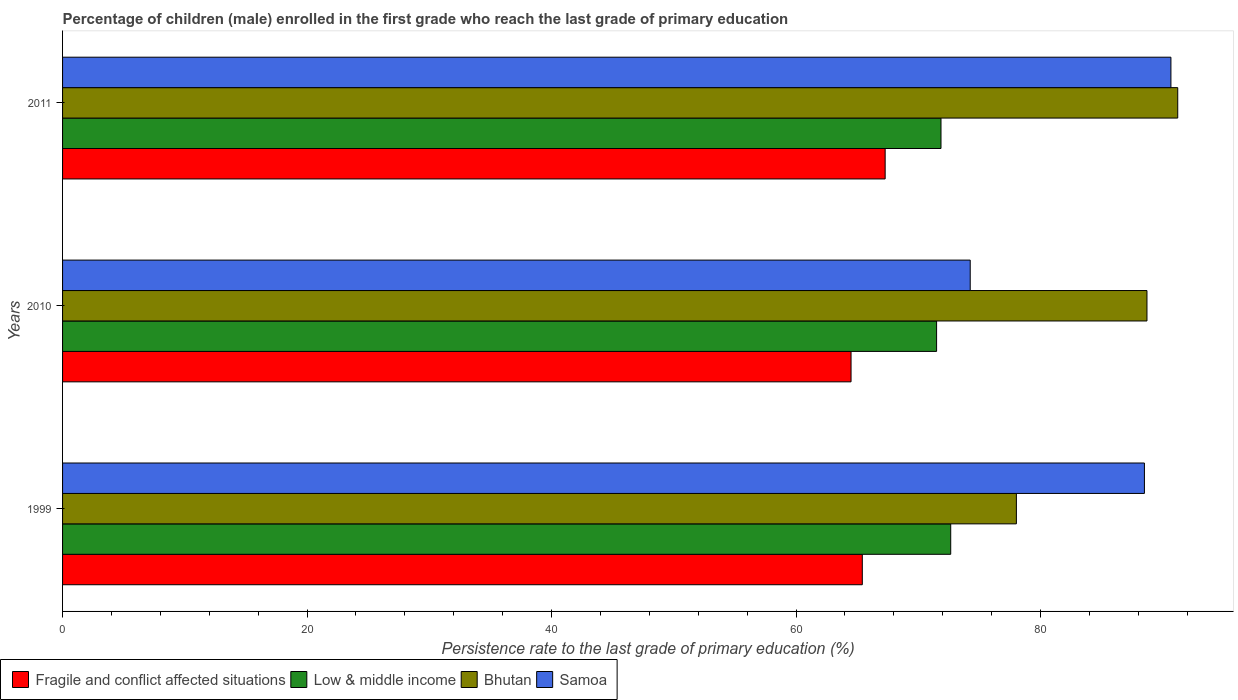How many different coloured bars are there?
Ensure brevity in your answer.  4. How many groups of bars are there?
Offer a very short reply. 3. Are the number of bars per tick equal to the number of legend labels?
Provide a succinct answer. Yes. How many bars are there on the 3rd tick from the top?
Provide a short and direct response. 4. How many bars are there on the 3rd tick from the bottom?
Your answer should be compact. 4. In how many cases, is the number of bars for a given year not equal to the number of legend labels?
Give a very brief answer. 0. What is the persistence rate of children in Fragile and conflict affected situations in 2010?
Provide a succinct answer. 64.5. Across all years, what is the maximum persistence rate of children in Low & middle income?
Ensure brevity in your answer.  72.65. Across all years, what is the minimum persistence rate of children in Fragile and conflict affected situations?
Provide a succinct answer. 64.5. In which year was the persistence rate of children in Bhutan maximum?
Keep it short and to the point. 2011. In which year was the persistence rate of children in Samoa minimum?
Give a very brief answer. 2010. What is the total persistence rate of children in Fragile and conflict affected situations in the graph?
Provide a succinct answer. 197.21. What is the difference between the persistence rate of children in Samoa in 2010 and that in 2011?
Provide a succinct answer. -16.42. What is the difference between the persistence rate of children in Low & middle income in 2010 and the persistence rate of children in Samoa in 2011?
Your answer should be very brief. -19.17. What is the average persistence rate of children in Low & middle income per year?
Make the answer very short. 72. In the year 2011, what is the difference between the persistence rate of children in Fragile and conflict affected situations and persistence rate of children in Samoa?
Your answer should be compact. -23.38. What is the ratio of the persistence rate of children in Fragile and conflict affected situations in 1999 to that in 2010?
Ensure brevity in your answer.  1.01. Is the persistence rate of children in Samoa in 2010 less than that in 2011?
Your answer should be very brief. Yes. What is the difference between the highest and the second highest persistence rate of children in Fragile and conflict affected situations?
Make the answer very short. 1.87. What is the difference between the highest and the lowest persistence rate of children in Fragile and conflict affected situations?
Provide a succinct answer. 2.79. Is the sum of the persistence rate of children in Low & middle income in 2010 and 2011 greater than the maximum persistence rate of children in Fragile and conflict affected situations across all years?
Provide a succinct answer. Yes. Is it the case that in every year, the sum of the persistence rate of children in Bhutan and persistence rate of children in Samoa is greater than the sum of persistence rate of children in Low & middle income and persistence rate of children in Fragile and conflict affected situations?
Your response must be concise. Yes. What does the 2nd bar from the top in 1999 represents?
Ensure brevity in your answer.  Bhutan. What does the 3rd bar from the bottom in 2010 represents?
Offer a terse response. Bhutan. Is it the case that in every year, the sum of the persistence rate of children in Fragile and conflict affected situations and persistence rate of children in Samoa is greater than the persistence rate of children in Low & middle income?
Offer a very short reply. Yes. Are all the bars in the graph horizontal?
Offer a terse response. Yes. Does the graph contain any zero values?
Make the answer very short. No. Does the graph contain grids?
Make the answer very short. No. Where does the legend appear in the graph?
Keep it short and to the point. Bottom left. What is the title of the graph?
Ensure brevity in your answer.  Percentage of children (male) enrolled in the first grade who reach the last grade of primary education. Does "South Asia" appear as one of the legend labels in the graph?
Your response must be concise. No. What is the label or title of the X-axis?
Your answer should be very brief. Persistence rate to the last grade of primary education (%). What is the Persistence rate to the last grade of primary education (%) of Fragile and conflict affected situations in 1999?
Give a very brief answer. 65.42. What is the Persistence rate to the last grade of primary education (%) of Low & middle income in 1999?
Give a very brief answer. 72.65. What is the Persistence rate to the last grade of primary education (%) in Bhutan in 1999?
Provide a short and direct response. 78.02. What is the Persistence rate to the last grade of primary education (%) of Samoa in 1999?
Offer a very short reply. 88.5. What is the Persistence rate to the last grade of primary education (%) in Fragile and conflict affected situations in 2010?
Your answer should be compact. 64.5. What is the Persistence rate to the last grade of primary education (%) of Low & middle income in 2010?
Your response must be concise. 71.49. What is the Persistence rate to the last grade of primary education (%) of Bhutan in 2010?
Offer a very short reply. 88.7. What is the Persistence rate to the last grade of primary education (%) of Samoa in 2010?
Give a very brief answer. 74.25. What is the Persistence rate to the last grade of primary education (%) in Fragile and conflict affected situations in 2011?
Your answer should be very brief. 67.29. What is the Persistence rate to the last grade of primary education (%) of Low & middle income in 2011?
Offer a terse response. 71.86. What is the Persistence rate to the last grade of primary education (%) in Bhutan in 2011?
Keep it short and to the point. 91.22. What is the Persistence rate to the last grade of primary education (%) in Samoa in 2011?
Keep it short and to the point. 90.66. Across all years, what is the maximum Persistence rate to the last grade of primary education (%) in Fragile and conflict affected situations?
Provide a short and direct response. 67.29. Across all years, what is the maximum Persistence rate to the last grade of primary education (%) in Low & middle income?
Offer a very short reply. 72.65. Across all years, what is the maximum Persistence rate to the last grade of primary education (%) in Bhutan?
Offer a terse response. 91.22. Across all years, what is the maximum Persistence rate to the last grade of primary education (%) of Samoa?
Your answer should be compact. 90.66. Across all years, what is the minimum Persistence rate to the last grade of primary education (%) of Fragile and conflict affected situations?
Provide a succinct answer. 64.5. Across all years, what is the minimum Persistence rate to the last grade of primary education (%) of Low & middle income?
Provide a short and direct response. 71.49. Across all years, what is the minimum Persistence rate to the last grade of primary education (%) in Bhutan?
Offer a very short reply. 78.02. Across all years, what is the minimum Persistence rate to the last grade of primary education (%) of Samoa?
Offer a very short reply. 74.25. What is the total Persistence rate to the last grade of primary education (%) in Fragile and conflict affected situations in the graph?
Your response must be concise. 197.21. What is the total Persistence rate to the last grade of primary education (%) of Low & middle income in the graph?
Ensure brevity in your answer.  216. What is the total Persistence rate to the last grade of primary education (%) of Bhutan in the graph?
Offer a terse response. 257.95. What is the total Persistence rate to the last grade of primary education (%) of Samoa in the graph?
Provide a succinct answer. 253.41. What is the difference between the Persistence rate to the last grade of primary education (%) of Fragile and conflict affected situations in 1999 and that in 2010?
Keep it short and to the point. 0.92. What is the difference between the Persistence rate to the last grade of primary education (%) of Low & middle income in 1999 and that in 2010?
Offer a very short reply. 1.16. What is the difference between the Persistence rate to the last grade of primary education (%) of Bhutan in 1999 and that in 2010?
Ensure brevity in your answer.  -10.68. What is the difference between the Persistence rate to the last grade of primary education (%) of Samoa in 1999 and that in 2010?
Your answer should be very brief. 14.25. What is the difference between the Persistence rate to the last grade of primary education (%) of Fragile and conflict affected situations in 1999 and that in 2011?
Ensure brevity in your answer.  -1.87. What is the difference between the Persistence rate to the last grade of primary education (%) in Low & middle income in 1999 and that in 2011?
Ensure brevity in your answer.  0.8. What is the difference between the Persistence rate to the last grade of primary education (%) of Bhutan in 1999 and that in 2011?
Offer a very short reply. -13.2. What is the difference between the Persistence rate to the last grade of primary education (%) of Samoa in 1999 and that in 2011?
Make the answer very short. -2.17. What is the difference between the Persistence rate to the last grade of primary education (%) of Fragile and conflict affected situations in 2010 and that in 2011?
Ensure brevity in your answer.  -2.79. What is the difference between the Persistence rate to the last grade of primary education (%) in Low & middle income in 2010 and that in 2011?
Ensure brevity in your answer.  -0.36. What is the difference between the Persistence rate to the last grade of primary education (%) in Bhutan in 2010 and that in 2011?
Offer a terse response. -2.52. What is the difference between the Persistence rate to the last grade of primary education (%) of Samoa in 2010 and that in 2011?
Make the answer very short. -16.42. What is the difference between the Persistence rate to the last grade of primary education (%) in Fragile and conflict affected situations in 1999 and the Persistence rate to the last grade of primary education (%) in Low & middle income in 2010?
Offer a terse response. -6.08. What is the difference between the Persistence rate to the last grade of primary education (%) in Fragile and conflict affected situations in 1999 and the Persistence rate to the last grade of primary education (%) in Bhutan in 2010?
Keep it short and to the point. -23.28. What is the difference between the Persistence rate to the last grade of primary education (%) in Fragile and conflict affected situations in 1999 and the Persistence rate to the last grade of primary education (%) in Samoa in 2010?
Your answer should be very brief. -8.83. What is the difference between the Persistence rate to the last grade of primary education (%) of Low & middle income in 1999 and the Persistence rate to the last grade of primary education (%) of Bhutan in 2010?
Make the answer very short. -16.05. What is the difference between the Persistence rate to the last grade of primary education (%) in Low & middle income in 1999 and the Persistence rate to the last grade of primary education (%) in Samoa in 2010?
Keep it short and to the point. -1.59. What is the difference between the Persistence rate to the last grade of primary education (%) in Bhutan in 1999 and the Persistence rate to the last grade of primary education (%) in Samoa in 2010?
Provide a succinct answer. 3.78. What is the difference between the Persistence rate to the last grade of primary education (%) in Fragile and conflict affected situations in 1999 and the Persistence rate to the last grade of primary education (%) in Low & middle income in 2011?
Offer a terse response. -6.44. What is the difference between the Persistence rate to the last grade of primary education (%) of Fragile and conflict affected situations in 1999 and the Persistence rate to the last grade of primary education (%) of Bhutan in 2011?
Ensure brevity in your answer.  -25.8. What is the difference between the Persistence rate to the last grade of primary education (%) in Fragile and conflict affected situations in 1999 and the Persistence rate to the last grade of primary education (%) in Samoa in 2011?
Offer a very short reply. -25.24. What is the difference between the Persistence rate to the last grade of primary education (%) of Low & middle income in 1999 and the Persistence rate to the last grade of primary education (%) of Bhutan in 2011?
Offer a terse response. -18.57. What is the difference between the Persistence rate to the last grade of primary education (%) of Low & middle income in 1999 and the Persistence rate to the last grade of primary education (%) of Samoa in 2011?
Keep it short and to the point. -18.01. What is the difference between the Persistence rate to the last grade of primary education (%) in Bhutan in 1999 and the Persistence rate to the last grade of primary education (%) in Samoa in 2011?
Your answer should be compact. -12.64. What is the difference between the Persistence rate to the last grade of primary education (%) of Fragile and conflict affected situations in 2010 and the Persistence rate to the last grade of primary education (%) of Low & middle income in 2011?
Your response must be concise. -7.36. What is the difference between the Persistence rate to the last grade of primary education (%) of Fragile and conflict affected situations in 2010 and the Persistence rate to the last grade of primary education (%) of Bhutan in 2011?
Provide a short and direct response. -26.72. What is the difference between the Persistence rate to the last grade of primary education (%) of Fragile and conflict affected situations in 2010 and the Persistence rate to the last grade of primary education (%) of Samoa in 2011?
Provide a succinct answer. -26.17. What is the difference between the Persistence rate to the last grade of primary education (%) of Low & middle income in 2010 and the Persistence rate to the last grade of primary education (%) of Bhutan in 2011?
Ensure brevity in your answer.  -19.73. What is the difference between the Persistence rate to the last grade of primary education (%) in Low & middle income in 2010 and the Persistence rate to the last grade of primary education (%) in Samoa in 2011?
Give a very brief answer. -19.17. What is the difference between the Persistence rate to the last grade of primary education (%) of Bhutan in 2010 and the Persistence rate to the last grade of primary education (%) of Samoa in 2011?
Your answer should be compact. -1.96. What is the average Persistence rate to the last grade of primary education (%) of Fragile and conflict affected situations per year?
Ensure brevity in your answer.  65.74. What is the average Persistence rate to the last grade of primary education (%) in Low & middle income per year?
Offer a very short reply. 72. What is the average Persistence rate to the last grade of primary education (%) of Bhutan per year?
Provide a succinct answer. 85.98. What is the average Persistence rate to the last grade of primary education (%) of Samoa per year?
Offer a terse response. 84.47. In the year 1999, what is the difference between the Persistence rate to the last grade of primary education (%) in Fragile and conflict affected situations and Persistence rate to the last grade of primary education (%) in Low & middle income?
Your answer should be very brief. -7.23. In the year 1999, what is the difference between the Persistence rate to the last grade of primary education (%) in Fragile and conflict affected situations and Persistence rate to the last grade of primary education (%) in Bhutan?
Ensure brevity in your answer.  -12.6. In the year 1999, what is the difference between the Persistence rate to the last grade of primary education (%) of Fragile and conflict affected situations and Persistence rate to the last grade of primary education (%) of Samoa?
Provide a short and direct response. -23.08. In the year 1999, what is the difference between the Persistence rate to the last grade of primary education (%) of Low & middle income and Persistence rate to the last grade of primary education (%) of Bhutan?
Your answer should be compact. -5.37. In the year 1999, what is the difference between the Persistence rate to the last grade of primary education (%) in Low & middle income and Persistence rate to the last grade of primary education (%) in Samoa?
Your answer should be compact. -15.85. In the year 1999, what is the difference between the Persistence rate to the last grade of primary education (%) in Bhutan and Persistence rate to the last grade of primary education (%) in Samoa?
Give a very brief answer. -10.47. In the year 2010, what is the difference between the Persistence rate to the last grade of primary education (%) in Fragile and conflict affected situations and Persistence rate to the last grade of primary education (%) in Low & middle income?
Ensure brevity in your answer.  -7. In the year 2010, what is the difference between the Persistence rate to the last grade of primary education (%) of Fragile and conflict affected situations and Persistence rate to the last grade of primary education (%) of Bhutan?
Keep it short and to the point. -24.21. In the year 2010, what is the difference between the Persistence rate to the last grade of primary education (%) in Fragile and conflict affected situations and Persistence rate to the last grade of primary education (%) in Samoa?
Offer a terse response. -9.75. In the year 2010, what is the difference between the Persistence rate to the last grade of primary education (%) in Low & middle income and Persistence rate to the last grade of primary education (%) in Bhutan?
Give a very brief answer. -17.21. In the year 2010, what is the difference between the Persistence rate to the last grade of primary education (%) in Low & middle income and Persistence rate to the last grade of primary education (%) in Samoa?
Your answer should be compact. -2.75. In the year 2010, what is the difference between the Persistence rate to the last grade of primary education (%) of Bhutan and Persistence rate to the last grade of primary education (%) of Samoa?
Offer a very short reply. 14.46. In the year 2011, what is the difference between the Persistence rate to the last grade of primary education (%) of Fragile and conflict affected situations and Persistence rate to the last grade of primary education (%) of Low & middle income?
Your answer should be compact. -4.57. In the year 2011, what is the difference between the Persistence rate to the last grade of primary education (%) of Fragile and conflict affected situations and Persistence rate to the last grade of primary education (%) of Bhutan?
Your answer should be compact. -23.93. In the year 2011, what is the difference between the Persistence rate to the last grade of primary education (%) in Fragile and conflict affected situations and Persistence rate to the last grade of primary education (%) in Samoa?
Offer a terse response. -23.38. In the year 2011, what is the difference between the Persistence rate to the last grade of primary education (%) of Low & middle income and Persistence rate to the last grade of primary education (%) of Bhutan?
Offer a terse response. -19.37. In the year 2011, what is the difference between the Persistence rate to the last grade of primary education (%) in Low & middle income and Persistence rate to the last grade of primary education (%) in Samoa?
Your answer should be very brief. -18.81. In the year 2011, what is the difference between the Persistence rate to the last grade of primary education (%) in Bhutan and Persistence rate to the last grade of primary education (%) in Samoa?
Ensure brevity in your answer.  0.56. What is the ratio of the Persistence rate to the last grade of primary education (%) in Fragile and conflict affected situations in 1999 to that in 2010?
Make the answer very short. 1.01. What is the ratio of the Persistence rate to the last grade of primary education (%) of Low & middle income in 1999 to that in 2010?
Keep it short and to the point. 1.02. What is the ratio of the Persistence rate to the last grade of primary education (%) in Bhutan in 1999 to that in 2010?
Ensure brevity in your answer.  0.88. What is the ratio of the Persistence rate to the last grade of primary education (%) in Samoa in 1999 to that in 2010?
Offer a very short reply. 1.19. What is the ratio of the Persistence rate to the last grade of primary education (%) in Fragile and conflict affected situations in 1999 to that in 2011?
Your answer should be very brief. 0.97. What is the ratio of the Persistence rate to the last grade of primary education (%) in Low & middle income in 1999 to that in 2011?
Your answer should be very brief. 1.01. What is the ratio of the Persistence rate to the last grade of primary education (%) in Bhutan in 1999 to that in 2011?
Give a very brief answer. 0.86. What is the ratio of the Persistence rate to the last grade of primary education (%) of Samoa in 1999 to that in 2011?
Your answer should be very brief. 0.98. What is the ratio of the Persistence rate to the last grade of primary education (%) of Fragile and conflict affected situations in 2010 to that in 2011?
Your answer should be very brief. 0.96. What is the ratio of the Persistence rate to the last grade of primary education (%) of Bhutan in 2010 to that in 2011?
Make the answer very short. 0.97. What is the ratio of the Persistence rate to the last grade of primary education (%) in Samoa in 2010 to that in 2011?
Make the answer very short. 0.82. What is the difference between the highest and the second highest Persistence rate to the last grade of primary education (%) of Fragile and conflict affected situations?
Your answer should be compact. 1.87. What is the difference between the highest and the second highest Persistence rate to the last grade of primary education (%) of Low & middle income?
Make the answer very short. 0.8. What is the difference between the highest and the second highest Persistence rate to the last grade of primary education (%) of Bhutan?
Make the answer very short. 2.52. What is the difference between the highest and the second highest Persistence rate to the last grade of primary education (%) in Samoa?
Ensure brevity in your answer.  2.17. What is the difference between the highest and the lowest Persistence rate to the last grade of primary education (%) of Fragile and conflict affected situations?
Ensure brevity in your answer.  2.79. What is the difference between the highest and the lowest Persistence rate to the last grade of primary education (%) in Low & middle income?
Offer a very short reply. 1.16. What is the difference between the highest and the lowest Persistence rate to the last grade of primary education (%) in Bhutan?
Offer a terse response. 13.2. What is the difference between the highest and the lowest Persistence rate to the last grade of primary education (%) of Samoa?
Offer a very short reply. 16.42. 